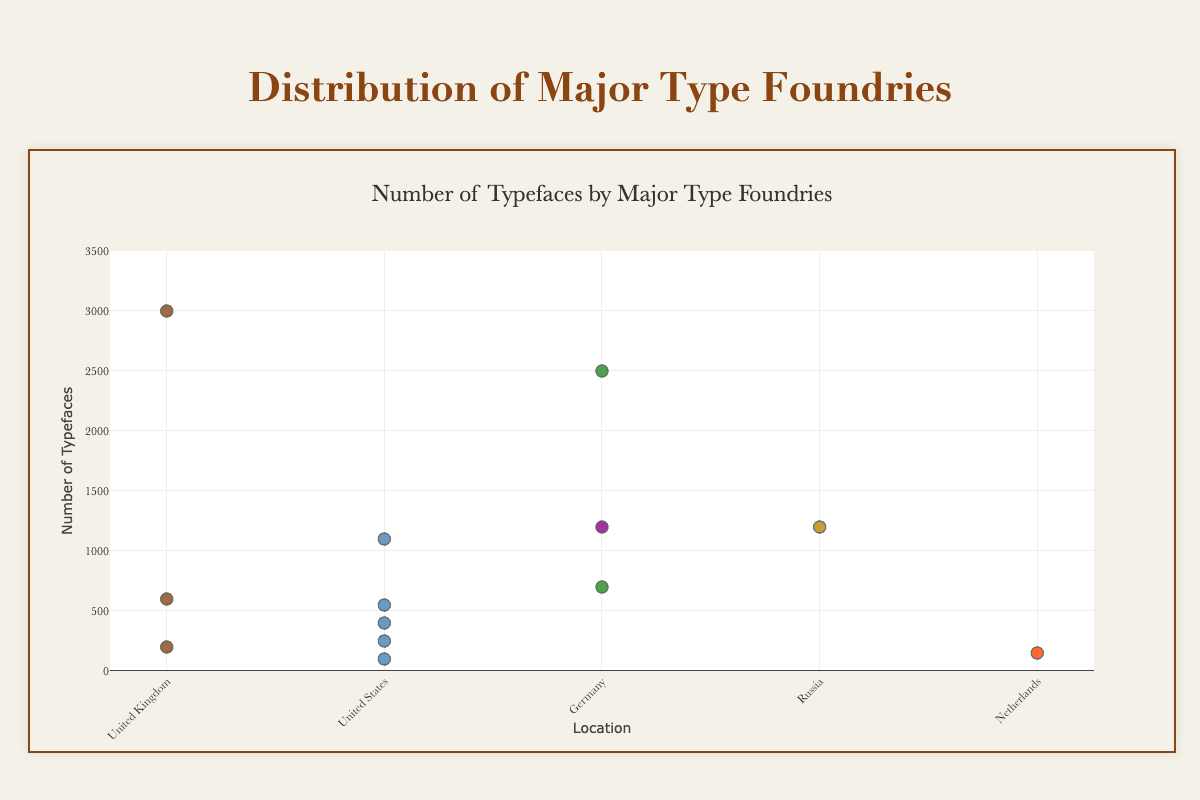What is the title of the scatter plot? The title of the figure is displayed prominently at the top and reads "Number of Typefaces by Major Type Foundries."
Answer: Number of Typefaces by Major Type Foundries Which type foundry has released the most number of typefaces? To find this, look for the marker with the highest y-value on the scatter plot. The foundry associated with this marker is Monotype.
Answer: Monotype How many typefaces has Adobe released? Locate the marker labeled "Adobe" on the plot, and its corresponding y-value reveals the number of typefaces, which is 550.
Answer: 550 Which country has the most type foundries represented in the plot? Count the occurrences of each country on the x-axis. The United States has the most occurrences with five foundries: Adobe, ITC, Hoefler & Co., Emigre, and House Industries.
Answer: United States Compare the number of typefaces released by Linotype and URW Type Foundry in Germany. Check the markers for Linotype and URW Type Foundry and note their y-values. Linotype has released 2500 typefaces, while URW Type Foundry has released 1200 typefaces.
Answer: Linotype has released more typefaces What is the average number of typefaces released by foundries based in the United States? Add the number of typefaces for all U.S.-based foundries (550 + 1100 + 250 + 400 + 100 = 2400) and divide by the number of foundries (5). The average is 2400 / 5.
Answer: 480 Which type foundry in the United Kingdom has released fewer typefaces, Dalton Maag or Commercial Type? Compare the y-values for Dalton Maag and Commercial Type. Dalton Maag has 600, and Commercial Type has 200.
Answer: Commercial Type If Paratype and ITC joined their typefaces, how many would they have together? Sum the number of typefaces released by Paratype and ITC (1200 + 1100). The total would be 2300.
Answer: 2300 What is the difference in the number of typefaces released by Monotype and Adobe? Subtract the number of typefaces released by Adobe from Monotype (3000 - 550).
Answer: 2450 